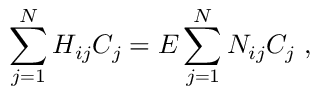<formula> <loc_0><loc_0><loc_500><loc_500>\sum _ { j = 1 } ^ { N } H _ { i j } C _ { j } = E \sum _ { j = 1 } ^ { N } N _ { i j } C _ { j } \ ,</formula> 